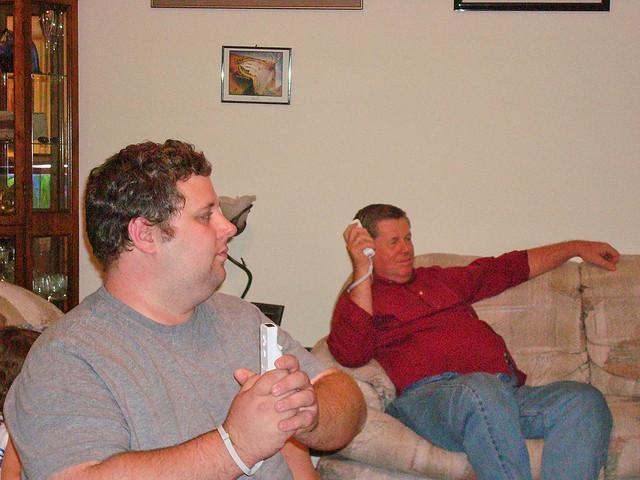How many remotes?
Give a very brief answer. 2. How many people in the picture are wearing glasses?
Give a very brief answer. 0. How many people are there?
Give a very brief answer. 2. How many couches can you see?
Give a very brief answer. 1. 